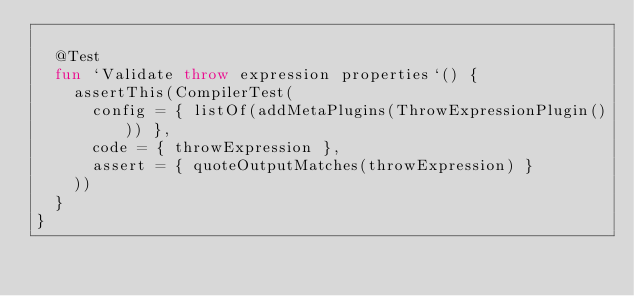<code> <loc_0><loc_0><loc_500><loc_500><_Kotlin_>
  @Test
  fun `Validate throw expression properties`() {
    assertThis(CompilerTest(
      config = { listOf(addMetaPlugins(ThrowExpressionPlugin())) },
      code = { throwExpression },
      assert = { quoteOutputMatches(throwExpression) }
    ))
  }
}
</code> 